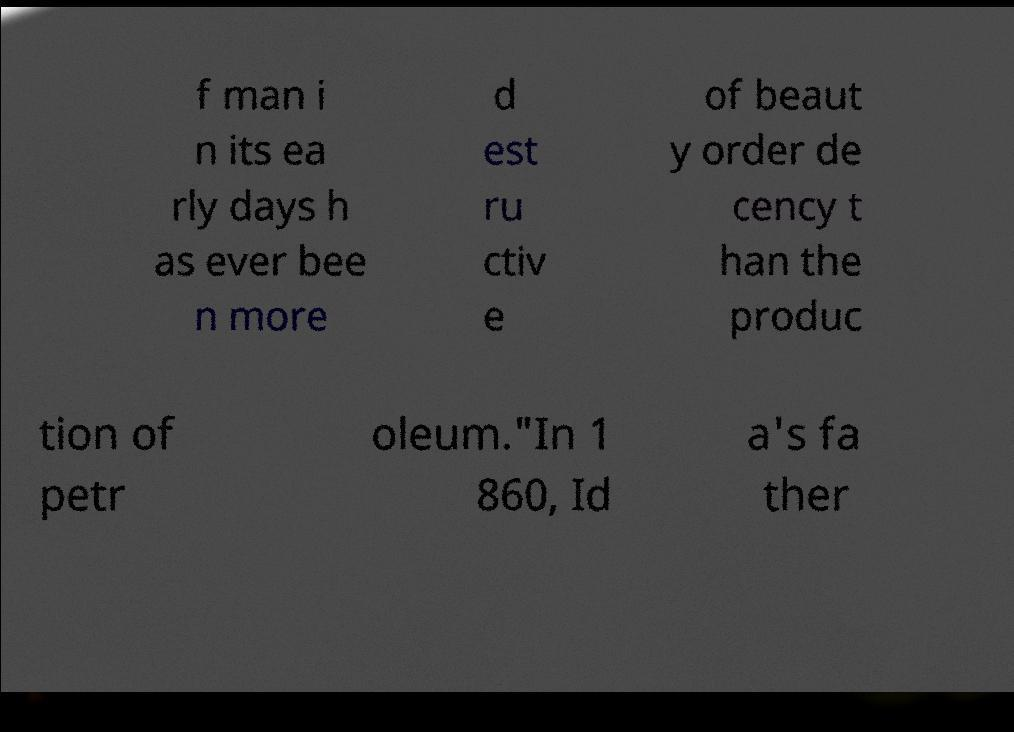Please read and relay the text visible in this image. What does it say? f man i n its ea rly days h as ever bee n more d est ru ctiv e of beaut y order de cency t han the produc tion of petr oleum."In 1 860, Id a's fa ther 